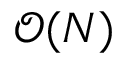<formula> <loc_0><loc_0><loc_500><loc_500>\mathcal { O } ( N )</formula> 